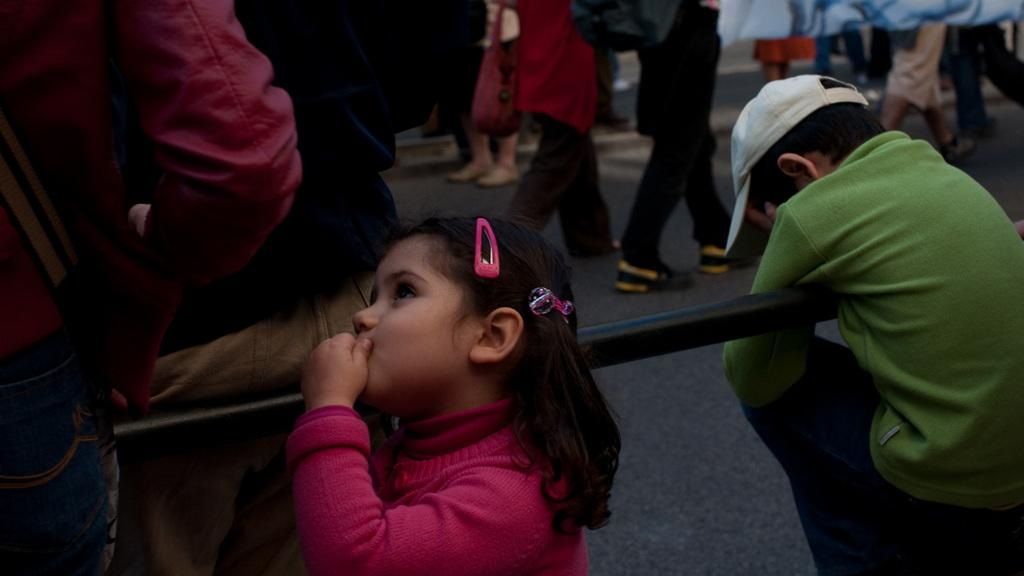What is the main subject of the image? The main subject of the image is a group of people. What are some of the people in the image doing? Some people are standing at a rod, while others are walking on the road. Can you describe the actions of the people in the image? The people standing at the rod are likely waiting or observing something, while the people walking on the road are moving from one place to another. What type of test can be seen being conducted on the road in the image? There is no test being conducted in the image; it simply shows people standing at a rod and walking on the road. What song is being sung by the people standing at the rod in the image? There is no indication in the image that the people standing at the rod are singing a song. 